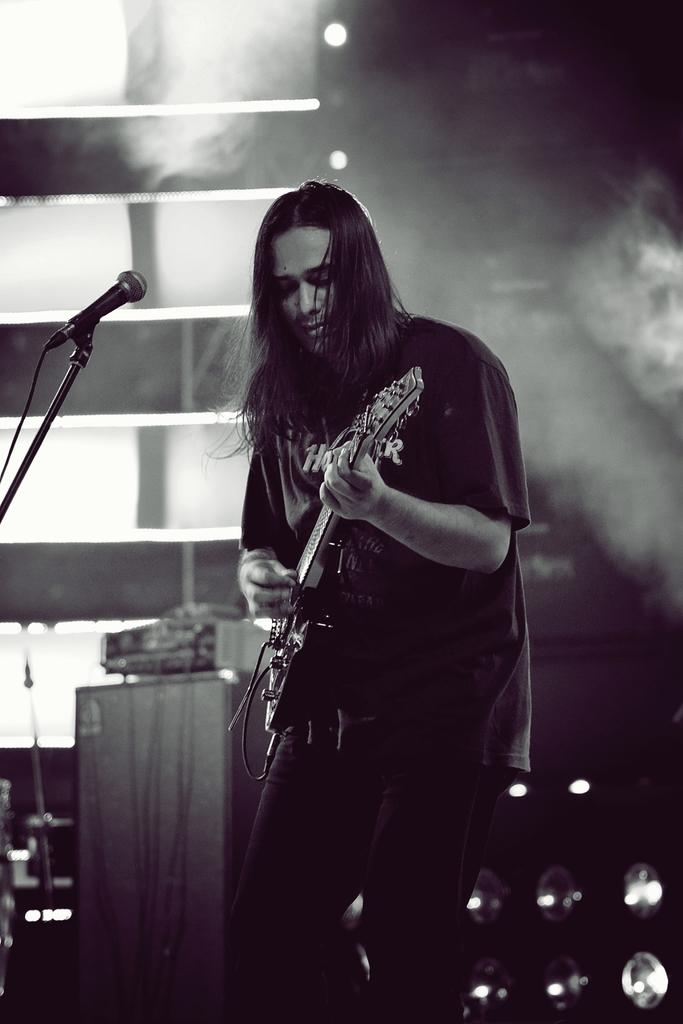What is the main subject of the image? There is a person in the image. What is the person doing in the image? The person is standing and holding a guitar in his hand. What object is in front of the person? There is a microphone with a stand in front of the person. What is the color scheme of the image? The image is in black and white color. What type of cable can be seen connecting the guitar to the amplifier in the image? There is no cable connecting the guitar to an amplifier in the image; the guitar is simply being held by the person. 